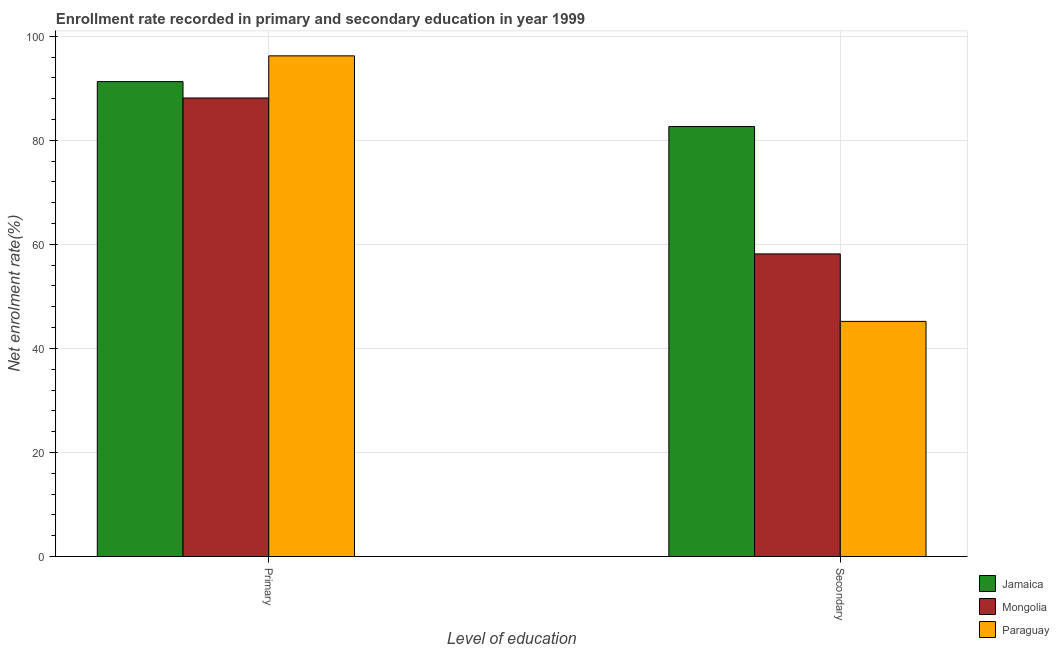How many different coloured bars are there?
Make the answer very short. 3. How many groups of bars are there?
Your answer should be very brief. 2. Are the number of bars per tick equal to the number of legend labels?
Your answer should be very brief. Yes. Are the number of bars on each tick of the X-axis equal?
Make the answer very short. Yes. How many bars are there on the 1st tick from the right?
Provide a short and direct response. 3. What is the label of the 1st group of bars from the left?
Provide a short and direct response. Primary. What is the enrollment rate in primary education in Paraguay?
Make the answer very short. 96.23. Across all countries, what is the maximum enrollment rate in primary education?
Offer a very short reply. 96.23. Across all countries, what is the minimum enrollment rate in secondary education?
Keep it short and to the point. 45.19. In which country was the enrollment rate in primary education maximum?
Provide a short and direct response. Paraguay. In which country was the enrollment rate in primary education minimum?
Your answer should be compact. Mongolia. What is the total enrollment rate in secondary education in the graph?
Your answer should be very brief. 186.01. What is the difference between the enrollment rate in secondary education in Mongolia and that in Jamaica?
Ensure brevity in your answer.  -24.48. What is the difference between the enrollment rate in secondary education in Paraguay and the enrollment rate in primary education in Jamaica?
Provide a short and direct response. -46.09. What is the average enrollment rate in primary education per country?
Make the answer very short. 91.88. What is the difference between the enrollment rate in primary education and enrollment rate in secondary education in Paraguay?
Keep it short and to the point. 51.03. What is the ratio of the enrollment rate in primary education in Jamaica to that in Paraguay?
Offer a very short reply. 0.95. In how many countries, is the enrollment rate in primary education greater than the average enrollment rate in primary education taken over all countries?
Provide a succinct answer. 1. What does the 3rd bar from the left in Secondary represents?
Your answer should be compact. Paraguay. What does the 1st bar from the right in Primary represents?
Offer a terse response. Paraguay. How many countries are there in the graph?
Offer a very short reply. 3. What is the difference between two consecutive major ticks on the Y-axis?
Your response must be concise. 20. Does the graph contain grids?
Your answer should be compact. Yes. What is the title of the graph?
Your answer should be compact. Enrollment rate recorded in primary and secondary education in year 1999. What is the label or title of the X-axis?
Give a very brief answer. Level of education. What is the label or title of the Y-axis?
Offer a very short reply. Net enrolment rate(%). What is the Net enrolment rate(%) of Jamaica in Primary?
Offer a terse response. 91.28. What is the Net enrolment rate(%) in Mongolia in Primary?
Your answer should be very brief. 88.13. What is the Net enrolment rate(%) in Paraguay in Primary?
Offer a terse response. 96.23. What is the Net enrolment rate(%) in Jamaica in Secondary?
Provide a short and direct response. 82.65. What is the Net enrolment rate(%) in Mongolia in Secondary?
Offer a terse response. 58.16. What is the Net enrolment rate(%) in Paraguay in Secondary?
Provide a short and direct response. 45.19. Across all Level of education, what is the maximum Net enrolment rate(%) of Jamaica?
Your answer should be compact. 91.28. Across all Level of education, what is the maximum Net enrolment rate(%) in Mongolia?
Keep it short and to the point. 88.13. Across all Level of education, what is the maximum Net enrolment rate(%) in Paraguay?
Keep it short and to the point. 96.23. Across all Level of education, what is the minimum Net enrolment rate(%) in Jamaica?
Offer a terse response. 82.65. Across all Level of education, what is the minimum Net enrolment rate(%) in Mongolia?
Your answer should be compact. 58.16. Across all Level of education, what is the minimum Net enrolment rate(%) in Paraguay?
Provide a succinct answer. 45.19. What is the total Net enrolment rate(%) in Jamaica in the graph?
Make the answer very short. 173.93. What is the total Net enrolment rate(%) of Mongolia in the graph?
Ensure brevity in your answer.  146.3. What is the total Net enrolment rate(%) in Paraguay in the graph?
Ensure brevity in your answer.  141.42. What is the difference between the Net enrolment rate(%) of Jamaica in Primary and that in Secondary?
Make the answer very short. 8.63. What is the difference between the Net enrolment rate(%) of Mongolia in Primary and that in Secondary?
Provide a succinct answer. 29.97. What is the difference between the Net enrolment rate(%) of Paraguay in Primary and that in Secondary?
Offer a very short reply. 51.03. What is the difference between the Net enrolment rate(%) of Jamaica in Primary and the Net enrolment rate(%) of Mongolia in Secondary?
Ensure brevity in your answer.  33.12. What is the difference between the Net enrolment rate(%) of Jamaica in Primary and the Net enrolment rate(%) of Paraguay in Secondary?
Offer a terse response. 46.09. What is the difference between the Net enrolment rate(%) of Mongolia in Primary and the Net enrolment rate(%) of Paraguay in Secondary?
Give a very brief answer. 42.94. What is the average Net enrolment rate(%) of Jamaica per Level of education?
Ensure brevity in your answer.  86.96. What is the average Net enrolment rate(%) of Mongolia per Level of education?
Your answer should be compact. 73.15. What is the average Net enrolment rate(%) of Paraguay per Level of education?
Offer a terse response. 70.71. What is the difference between the Net enrolment rate(%) in Jamaica and Net enrolment rate(%) in Mongolia in Primary?
Provide a short and direct response. 3.15. What is the difference between the Net enrolment rate(%) in Jamaica and Net enrolment rate(%) in Paraguay in Primary?
Make the answer very short. -4.95. What is the difference between the Net enrolment rate(%) of Mongolia and Net enrolment rate(%) of Paraguay in Primary?
Offer a very short reply. -8.1. What is the difference between the Net enrolment rate(%) of Jamaica and Net enrolment rate(%) of Mongolia in Secondary?
Give a very brief answer. 24.48. What is the difference between the Net enrolment rate(%) of Jamaica and Net enrolment rate(%) of Paraguay in Secondary?
Your response must be concise. 37.45. What is the difference between the Net enrolment rate(%) of Mongolia and Net enrolment rate(%) of Paraguay in Secondary?
Provide a short and direct response. 12.97. What is the ratio of the Net enrolment rate(%) in Jamaica in Primary to that in Secondary?
Provide a succinct answer. 1.1. What is the ratio of the Net enrolment rate(%) of Mongolia in Primary to that in Secondary?
Your answer should be very brief. 1.52. What is the ratio of the Net enrolment rate(%) in Paraguay in Primary to that in Secondary?
Your answer should be very brief. 2.13. What is the difference between the highest and the second highest Net enrolment rate(%) in Jamaica?
Give a very brief answer. 8.63. What is the difference between the highest and the second highest Net enrolment rate(%) of Mongolia?
Your answer should be very brief. 29.97. What is the difference between the highest and the second highest Net enrolment rate(%) of Paraguay?
Offer a terse response. 51.03. What is the difference between the highest and the lowest Net enrolment rate(%) in Jamaica?
Make the answer very short. 8.63. What is the difference between the highest and the lowest Net enrolment rate(%) in Mongolia?
Your response must be concise. 29.97. What is the difference between the highest and the lowest Net enrolment rate(%) of Paraguay?
Your answer should be compact. 51.03. 